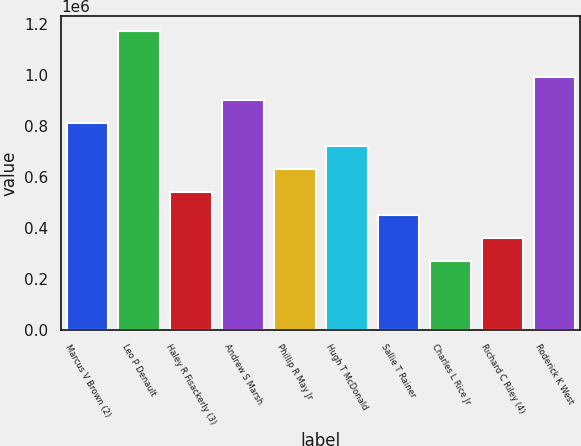Convert chart. <chart><loc_0><loc_0><loc_500><loc_500><bar_chart><fcel>Marcus V Brown (2)<fcel>Leo P Denault<fcel>Haley R Fisackerly (3)<fcel>Andrew S Marsh<fcel>Phillip R May Jr<fcel>Hugh T McDonald<fcel>Sallie T Rainer<fcel>Charles L Rice Jr<fcel>Richard C Riley (4)<fcel>Roderick K West<nl><fcel>809388<fcel>1.17e+06<fcel>538929<fcel>899541<fcel>629082<fcel>719235<fcel>448776<fcel>268470<fcel>358623<fcel>989694<nl></chart> 